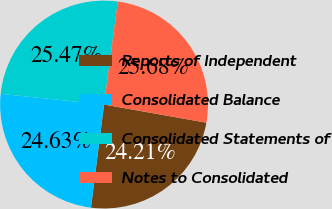<chart> <loc_0><loc_0><loc_500><loc_500><pie_chart><fcel>Reports of Independent<fcel>Consolidated Balance<fcel>Consolidated Statements of<fcel>Notes to Consolidated<nl><fcel>24.21%<fcel>24.63%<fcel>25.47%<fcel>25.68%<nl></chart> 